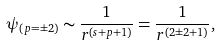Convert formula to latex. <formula><loc_0><loc_0><loc_500><loc_500>\psi _ { \left ( p = \pm 2 \right ) } \sim \frac { 1 } { r ^ { ( s + p + 1 ) } } = \frac { 1 } { r ^ { \left ( 2 \pm 2 + 1 \right ) } } ,</formula> 